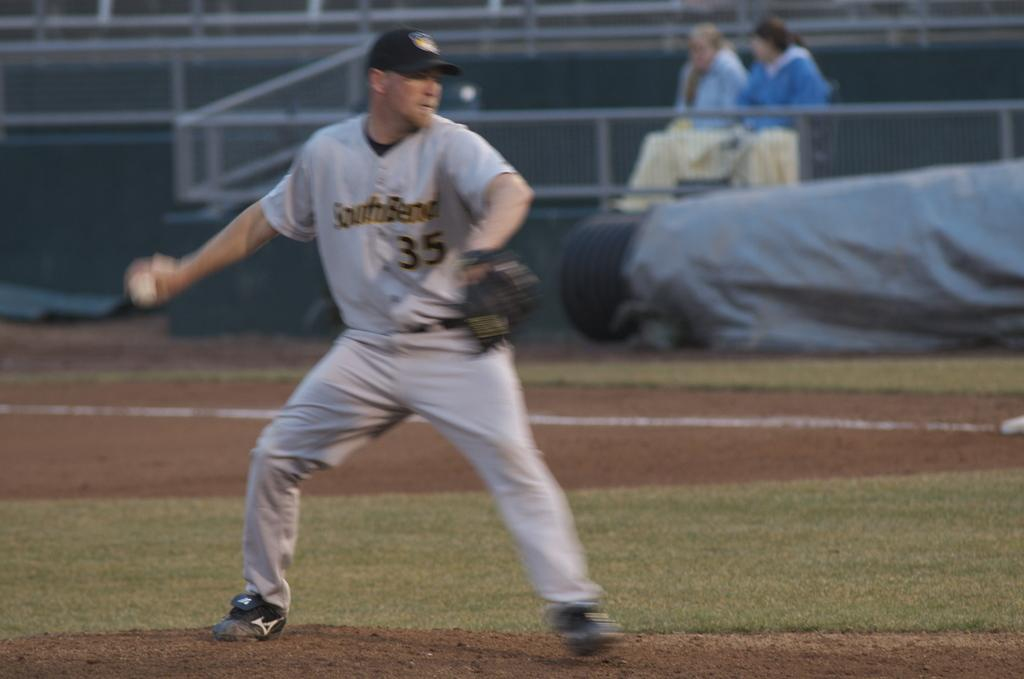<image>
Share a concise interpretation of the image provided. A baseball player with a Southbend jersey on makes a throw. 